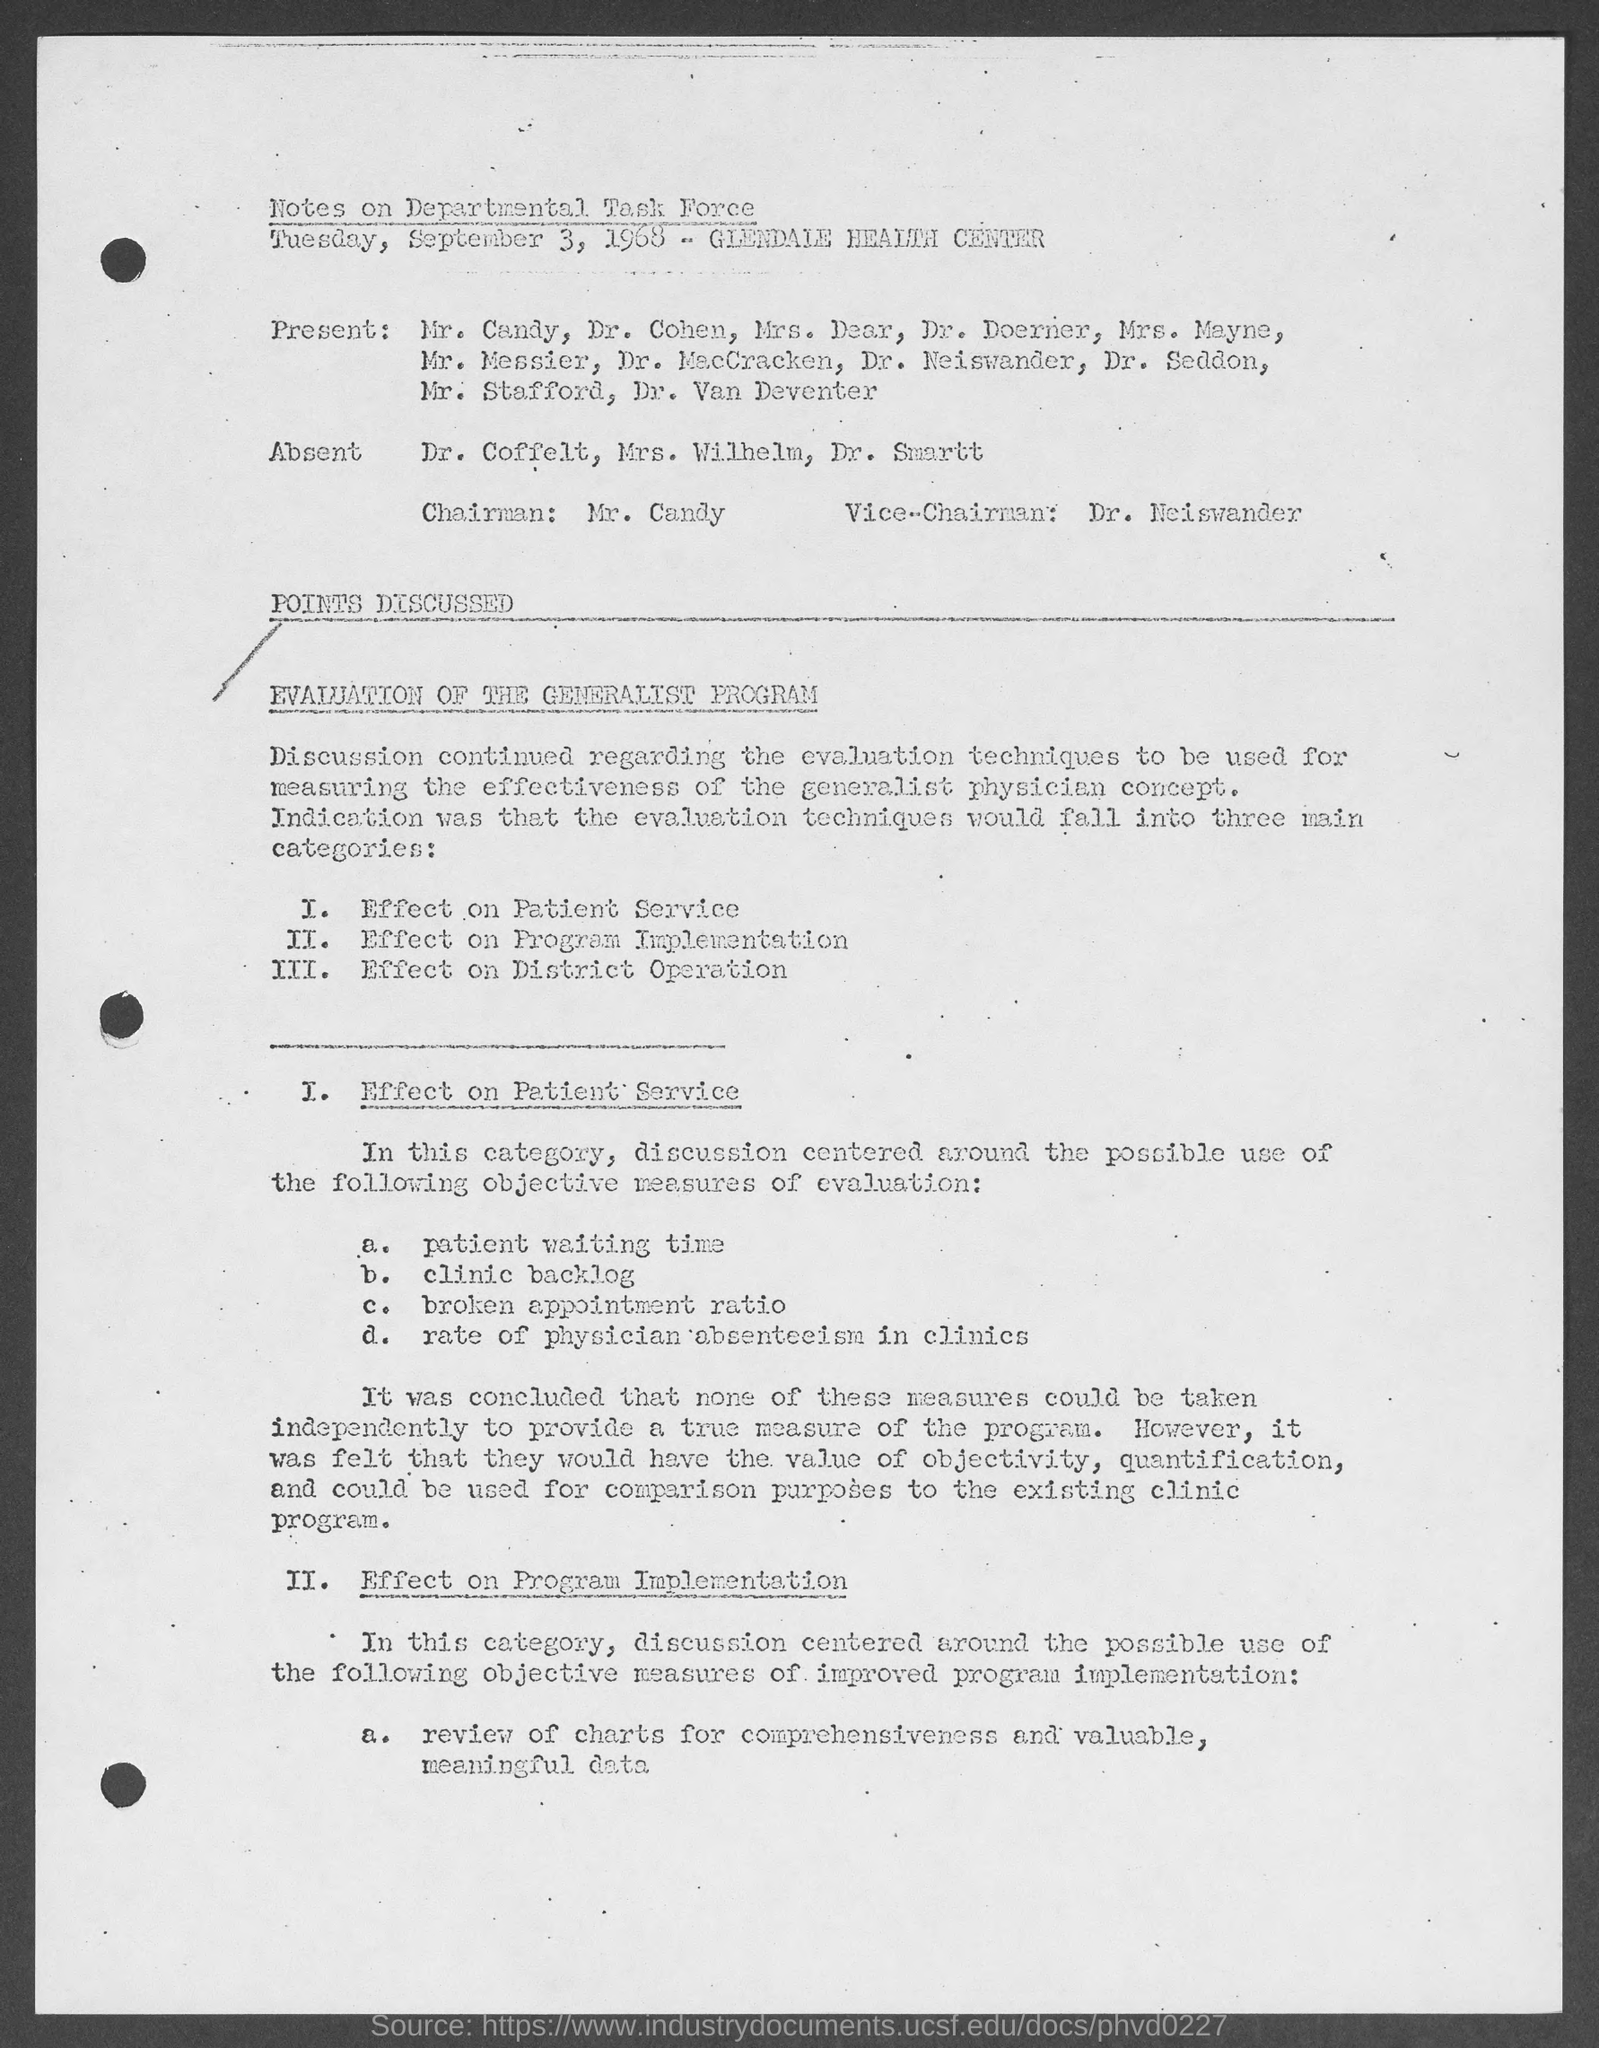Who is the Chairman mentioned in the document?
 mr. candy 